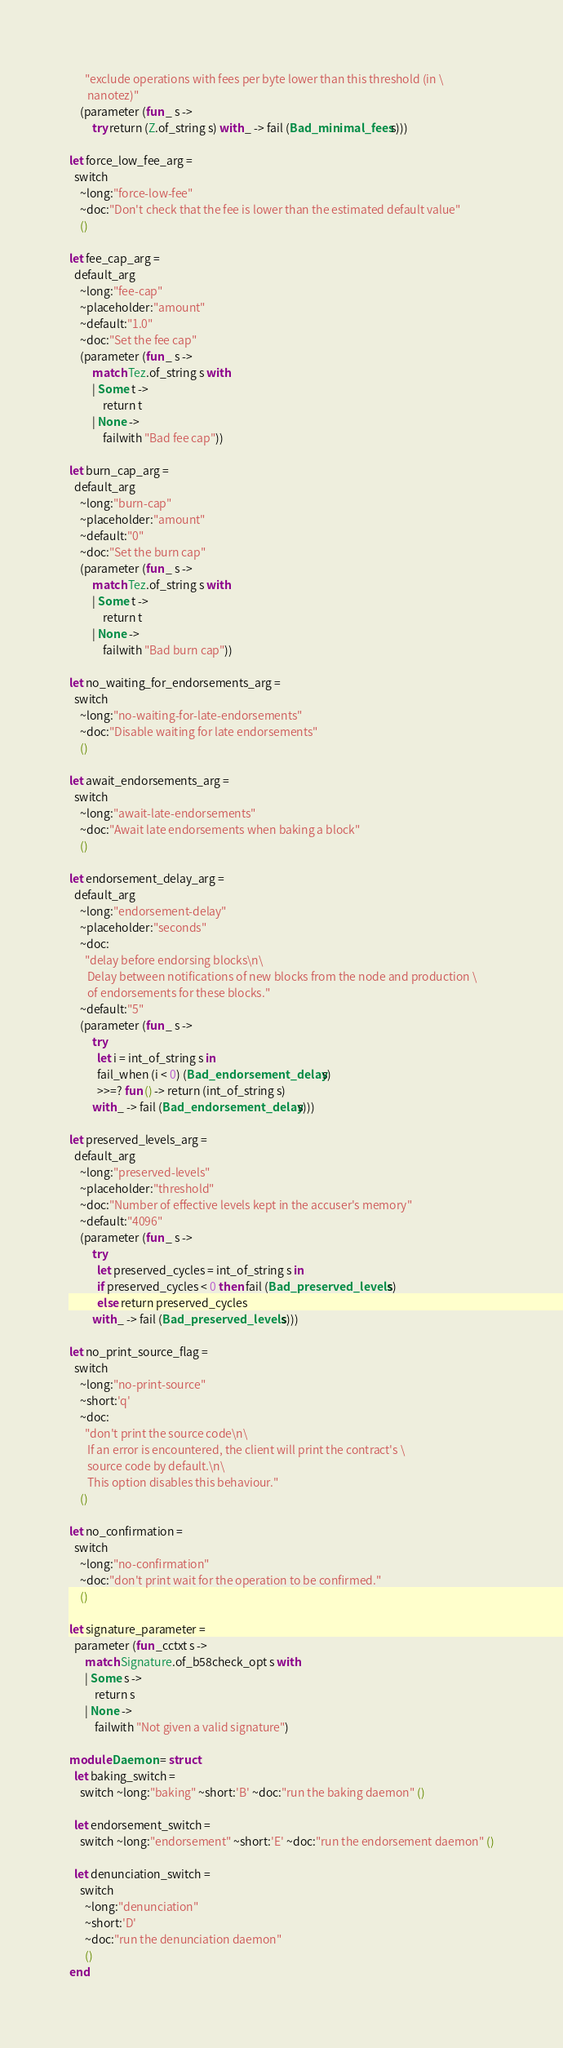<code> <loc_0><loc_0><loc_500><loc_500><_OCaml_>      "exclude operations with fees per byte lower than this threshold (in \
       nanotez)"
    (parameter (fun _ s ->
         try return (Z.of_string s) with _ -> fail (Bad_minimal_fees s)))

let force_low_fee_arg =
  switch
    ~long:"force-low-fee"
    ~doc:"Don't check that the fee is lower than the estimated default value"
    ()

let fee_cap_arg =
  default_arg
    ~long:"fee-cap"
    ~placeholder:"amount"
    ~default:"1.0"
    ~doc:"Set the fee cap"
    (parameter (fun _ s ->
         match Tez.of_string s with
         | Some t ->
             return t
         | None ->
             failwith "Bad fee cap"))

let burn_cap_arg =
  default_arg
    ~long:"burn-cap"
    ~placeholder:"amount"
    ~default:"0"
    ~doc:"Set the burn cap"
    (parameter (fun _ s ->
         match Tez.of_string s with
         | Some t ->
             return t
         | None ->
             failwith "Bad burn cap"))

let no_waiting_for_endorsements_arg =
  switch
    ~long:"no-waiting-for-late-endorsements"
    ~doc:"Disable waiting for late endorsements"
    ()

let await_endorsements_arg =
  switch
    ~long:"await-late-endorsements"
    ~doc:"Await late endorsements when baking a block"
    ()

let endorsement_delay_arg =
  default_arg
    ~long:"endorsement-delay"
    ~placeholder:"seconds"
    ~doc:
      "delay before endorsing blocks\n\
       Delay between notifications of new blocks from the node and production \
       of endorsements for these blocks."
    ~default:"5"
    (parameter (fun _ s ->
         try
           let i = int_of_string s in
           fail_when (i < 0) (Bad_endorsement_delay s)
           >>=? fun () -> return (int_of_string s)
         with _ -> fail (Bad_endorsement_delay s)))

let preserved_levels_arg =
  default_arg
    ~long:"preserved-levels"
    ~placeholder:"threshold"
    ~doc:"Number of effective levels kept in the accuser's memory"
    ~default:"4096"
    (parameter (fun _ s ->
         try
           let preserved_cycles = int_of_string s in
           if preserved_cycles < 0 then fail (Bad_preserved_levels s)
           else return preserved_cycles
         with _ -> fail (Bad_preserved_levels s)))

let no_print_source_flag =
  switch
    ~long:"no-print-source"
    ~short:'q'
    ~doc:
      "don't print the source code\n\
       If an error is encountered, the client will print the contract's \
       source code by default.\n\
       This option disables this behaviour."
    ()

let no_confirmation =
  switch
    ~long:"no-confirmation"
    ~doc:"don't print wait for the operation to be confirmed."
    ()

let signature_parameter =
  parameter (fun _cctxt s ->
      match Signature.of_b58check_opt s with
      | Some s ->
          return s
      | None ->
          failwith "Not given a valid signature")

module Daemon = struct
  let baking_switch =
    switch ~long:"baking" ~short:'B' ~doc:"run the baking daemon" ()

  let endorsement_switch =
    switch ~long:"endorsement" ~short:'E' ~doc:"run the endorsement daemon" ()

  let denunciation_switch =
    switch
      ~long:"denunciation"
      ~short:'D'
      ~doc:"run the denunciation daemon"
      ()
end
</code> 